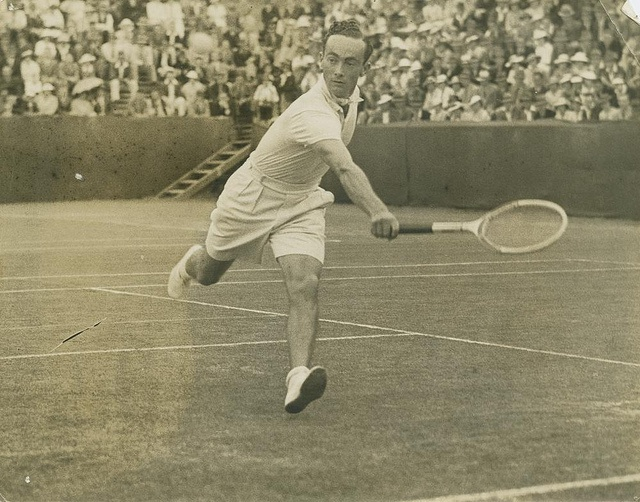Describe the objects in this image and their specific colors. I can see people in tan, gray, and beige tones, tennis racket in tan and gray tones, people in tan and darkgreen tones, people in tan tones, and people in tan and darkgreen tones in this image. 